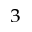Convert formula to latex. <formula><loc_0><loc_0><loc_500><loc_500>^ { 3 }</formula> 